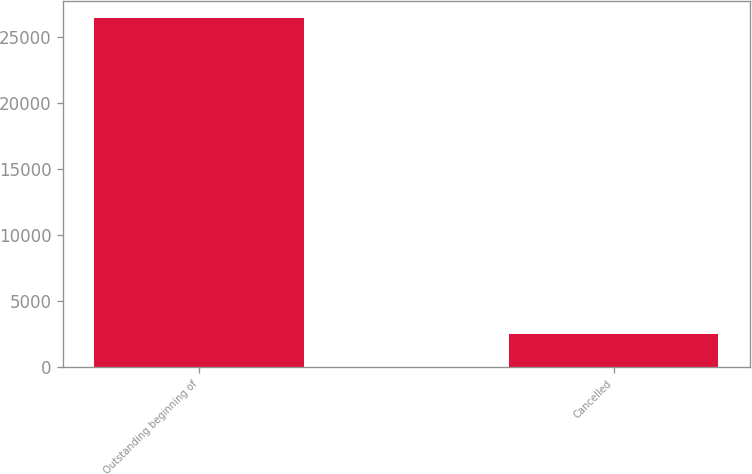Convert chart. <chart><loc_0><loc_0><loc_500><loc_500><bar_chart><fcel>Outstanding beginning of<fcel>Cancelled<nl><fcel>26403<fcel>2511<nl></chart> 